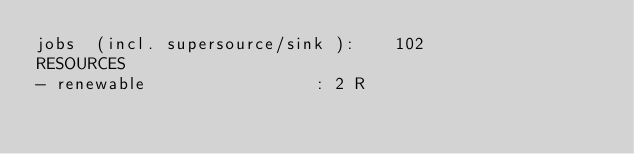Convert code to text. <code><loc_0><loc_0><loc_500><loc_500><_ObjectiveC_>jobs  (incl. supersource/sink ):	102
RESOURCES
- renewable                 : 2 R</code> 